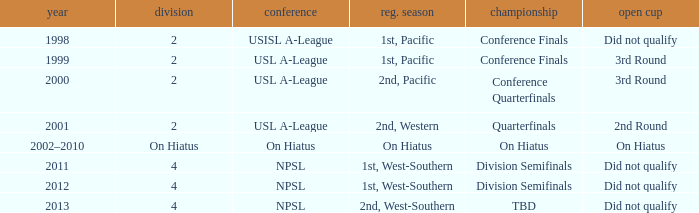When did the usl a-league have conference finals? 1999.0. 